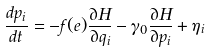<formula> <loc_0><loc_0><loc_500><loc_500>\frac { d p _ { i } } { d t } = - f ( e ) \frac { \partial H } { \partial q _ { i } } - \gamma _ { 0 } \frac { \partial H } { \partial p _ { i } } + \eta _ { i }</formula> 